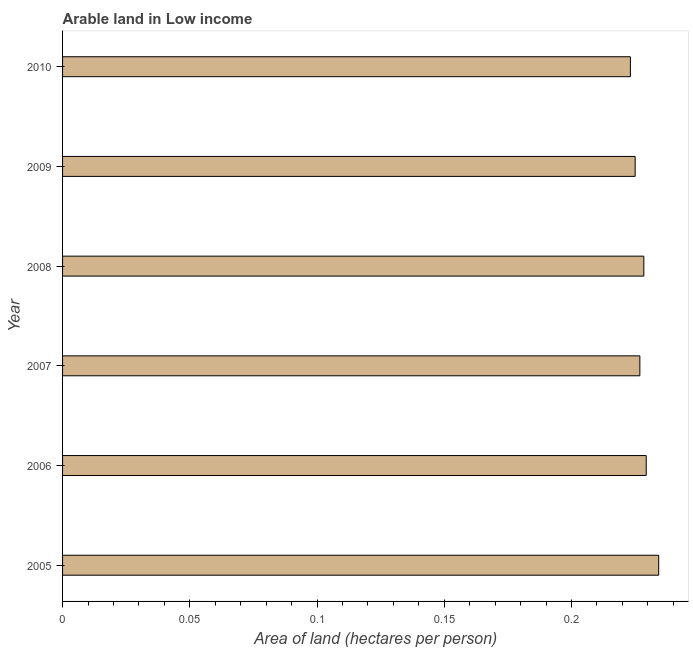What is the title of the graph?
Keep it short and to the point. Arable land in Low income. What is the label or title of the X-axis?
Your response must be concise. Area of land (hectares per person). What is the area of arable land in 2006?
Provide a succinct answer. 0.23. Across all years, what is the maximum area of arable land?
Ensure brevity in your answer.  0.23. Across all years, what is the minimum area of arable land?
Make the answer very short. 0.22. What is the sum of the area of arable land?
Provide a short and direct response. 1.37. What is the difference between the area of arable land in 2005 and 2007?
Your response must be concise. 0.01. What is the average area of arable land per year?
Provide a short and direct response. 0.23. What is the median area of arable land?
Give a very brief answer. 0.23. Is the area of arable land in 2006 less than that in 2008?
Your answer should be compact. No. What is the difference between the highest and the second highest area of arable land?
Offer a very short reply. 0.01. What is the difference between the highest and the lowest area of arable land?
Make the answer very short. 0.01. Are the values on the major ticks of X-axis written in scientific E-notation?
Your response must be concise. No. What is the Area of land (hectares per person) of 2005?
Ensure brevity in your answer.  0.23. What is the Area of land (hectares per person) of 2006?
Provide a short and direct response. 0.23. What is the Area of land (hectares per person) in 2007?
Your response must be concise. 0.23. What is the Area of land (hectares per person) of 2008?
Provide a succinct answer. 0.23. What is the Area of land (hectares per person) in 2009?
Provide a short and direct response. 0.23. What is the Area of land (hectares per person) of 2010?
Offer a terse response. 0.22. What is the difference between the Area of land (hectares per person) in 2005 and 2006?
Your answer should be very brief. 0. What is the difference between the Area of land (hectares per person) in 2005 and 2007?
Your answer should be very brief. 0.01. What is the difference between the Area of land (hectares per person) in 2005 and 2008?
Provide a short and direct response. 0.01. What is the difference between the Area of land (hectares per person) in 2005 and 2009?
Give a very brief answer. 0.01. What is the difference between the Area of land (hectares per person) in 2005 and 2010?
Offer a very short reply. 0.01. What is the difference between the Area of land (hectares per person) in 2006 and 2007?
Keep it short and to the point. 0. What is the difference between the Area of land (hectares per person) in 2006 and 2008?
Your answer should be compact. 0. What is the difference between the Area of land (hectares per person) in 2006 and 2009?
Ensure brevity in your answer.  0. What is the difference between the Area of land (hectares per person) in 2006 and 2010?
Your response must be concise. 0.01. What is the difference between the Area of land (hectares per person) in 2007 and 2008?
Give a very brief answer. -0. What is the difference between the Area of land (hectares per person) in 2007 and 2009?
Ensure brevity in your answer.  0. What is the difference between the Area of land (hectares per person) in 2007 and 2010?
Make the answer very short. 0. What is the difference between the Area of land (hectares per person) in 2008 and 2009?
Provide a short and direct response. 0. What is the difference between the Area of land (hectares per person) in 2008 and 2010?
Keep it short and to the point. 0.01. What is the difference between the Area of land (hectares per person) in 2009 and 2010?
Provide a short and direct response. 0. What is the ratio of the Area of land (hectares per person) in 2005 to that in 2007?
Make the answer very short. 1.03. What is the ratio of the Area of land (hectares per person) in 2005 to that in 2008?
Make the answer very short. 1.03. What is the ratio of the Area of land (hectares per person) in 2005 to that in 2009?
Offer a very short reply. 1.04. What is the ratio of the Area of land (hectares per person) in 2005 to that in 2010?
Make the answer very short. 1.05. What is the ratio of the Area of land (hectares per person) in 2006 to that in 2008?
Your answer should be very brief. 1. What is the ratio of the Area of land (hectares per person) in 2006 to that in 2009?
Offer a terse response. 1.02. What is the ratio of the Area of land (hectares per person) in 2006 to that in 2010?
Provide a succinct answer. 1.03. What is the ratio of the Area of land (hectares per person) in 2007 to that in 2008?
Make the answer very short. 0.99. What is the ratio of the Area of land (hectares per person) in 2007 to that in 2009?
Give a very brief answer. 1.01. What is the ratio of the Area of land (hectares per person) in 2007 to that in 2010?
Make the answer very short. 1.02. What is the ratio of the Area of land (hectares per person) in 2008 to that in 2009?
Offer a very short reply. 1.01. What is the ratio of the Area of land (hectares per person) in 2009 to that in 2010?
Offer a terse response. 1.01. 